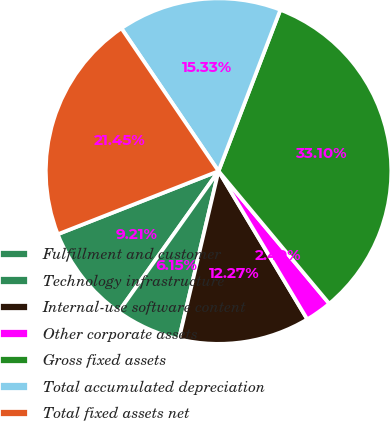Convert chart to OTSL. <chart><loc_0><loc_0><loc_500><loc_500><pie_chart><fcel>Fulfillment and customer<fcel>Technology infrastructure<fcel>Internal-use software content<fcel>Other corporate assets<fcel>Gross fixed assets<fcel>Total accumulated depreciation<fcel>Total fixed assets net<nl><fcel>9.21%<fcel>6.15%<fcel>12.27%<fcel>2.49%<fcel>33.1%<fcel>15.33%<fcel>21.45%<nl></chart> 